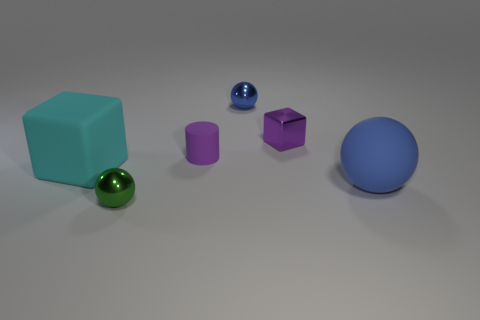How many big matte objects are in front of the tiny shiny sphere that is in front of the rubber object in front of the big cube?
Keep it short and to the point. 0. How many large things are blue metal things or blue objects?
Make the answer very short. 1. Are the large object that is in front of the big matte cube and the tiny block made of the same material?
Your answer should be very brief. No. What is the material of the large object behind the sphere that is on the right side of the blue object on the left side of the large matte sphere?
Ensure brevity in your answer.  Rubber. What number of shiny things are either red balls or big objects?
Offer a terse response. 0. Is there a tiny cyan matte object?
Give a very brief answer. No. What is the color of the sphere that is on the left side of the tiny thing that is behind the purple metallic block?
Provide a succinct answer. Green. What number of other things are the same color as the cylinder?
Provide a succinct answer. 1. How many things are either small cylinders or spheres to the right of the tiny cylinder?
Ensure brevity in your answer.  3. What is the color of the big thing that is to the right of the tiny blue shiny object?
Offer a very short reply. Blue. 